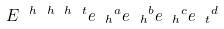<formula> <loc_0><loc_0><loc_500><loc_500>E ^ { \ h \ h \ h \ t } { e _ { \ h } } ^ { a } { e _ { \ h } } ^ { b } { e _ { \ h } } ^ { c } { e _ { \ t } } ^ { d }</formula> 